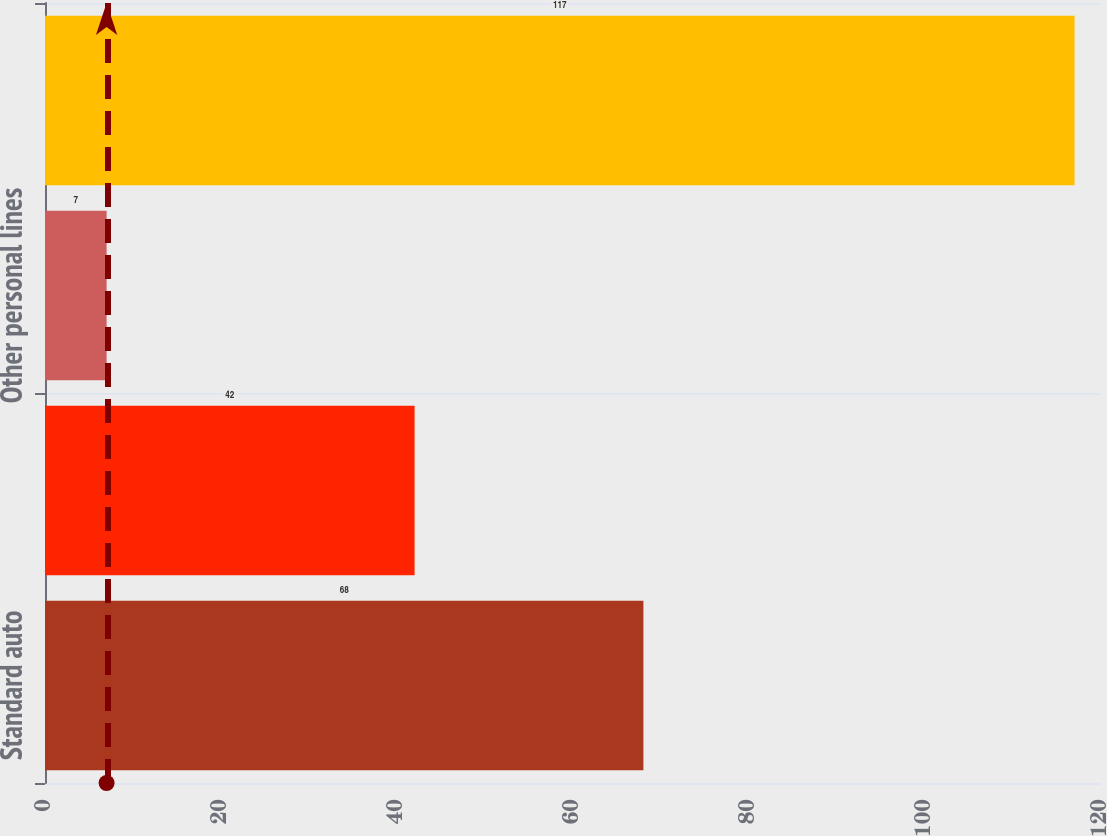Convert chart to OTSL. <chart><loc_0><loc_0><loc_500><loc_500><bar_chart><fcel>Standard auto<fcel>Homeowners<fcel>Other personal lines<fcel>Total DAC<nl><fcel>68<fcel>42<fcel>7<fcel>117<nl></chart> 